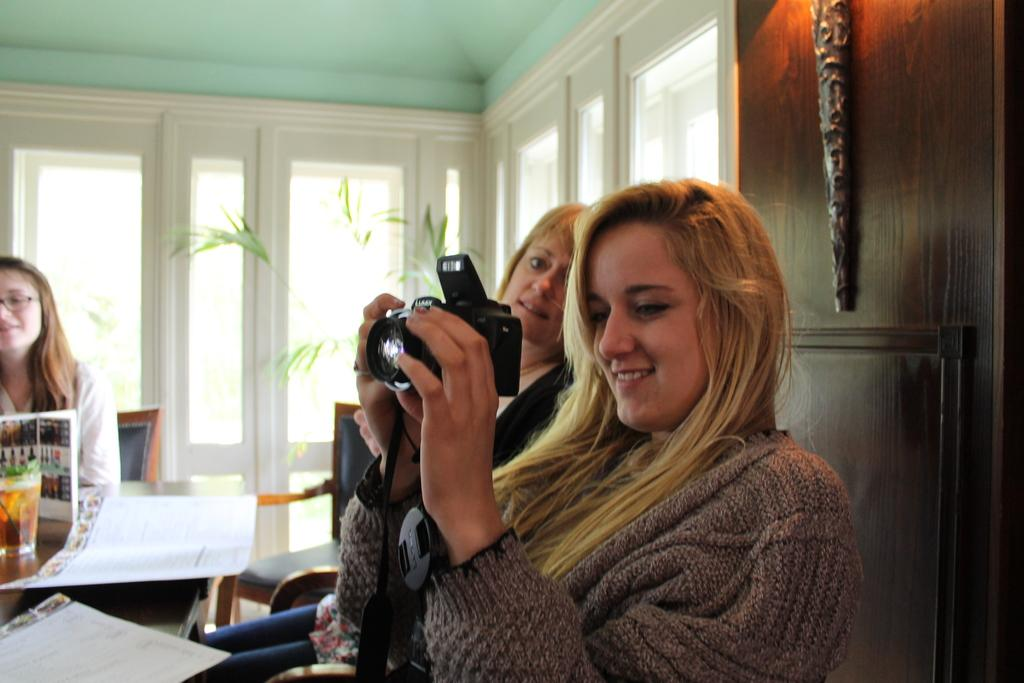How many women are present in the image? There are three women in the image. What are the women doing in the image? The women are sitting on a table. Can you describe what one of the women is holding? One of the women is holding a camera. What can be seen in the background of the image? There are glass doors and a wooden wall in the background of the image. What type of lace can be seen on the women's clothing in the image? There is no lace visible on the women's clothing in the image. What rhythm are the women following while sitting on the table? The women are not following any rhythm in the image; they are simply sitting on the table. 